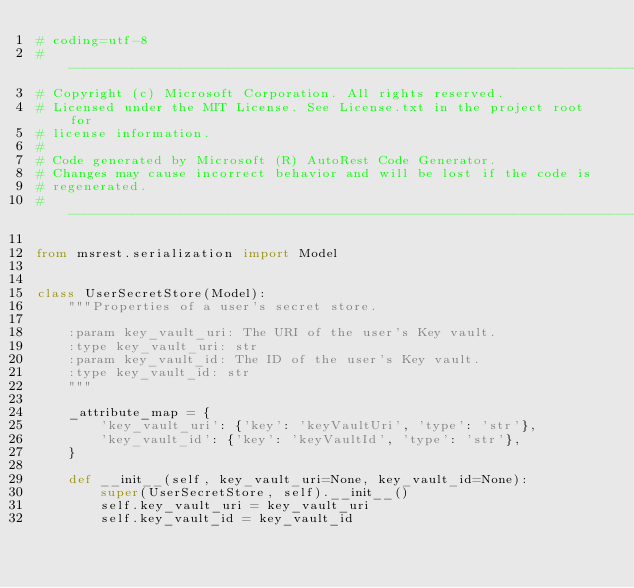Convert code to text. <code><loc_0><loc_0><loc_500><loc_500><_Python_># coding=utf-8
# --------------------------------------------------------------------------
# Copyright (c) Microsoft Corporation. All rights reserved.
# Licensed under the MIT License. See License.txt in the project root for
# license information.
#
# Code generated by Microsoft (R) AutoRest Code Generator.
# Changes may cause incorrect behavior and will be lost if the code is
# regenerated.
# --------------------------------------------------------------------------

from msrest.serialization import Model


class UserSecretStore(Model):
    """Properties of a user's secret store.

    :param key_vault_uri: The URI of the user's Key vault.
    :type key_vault_uri: str
    :param key_vault_id: The ID of the user's Key vault.
    :type key_vault_id: str
    """

    _attribute_map = {
        'key_vault_uri': {'key': 'keyVaultUri', 'type': 'str'},
        'key_vault_id': {'key': 'keyVaultId', 'type': 'str'},
    }

    def __init__(self, key_vault_uri=None, key_vault_id=None):
        super(UserSecretStore, self).__init__()
        self.key_vault_uri = key_vault_uri
        self.key_vault_id = key_vault_id
</code> 